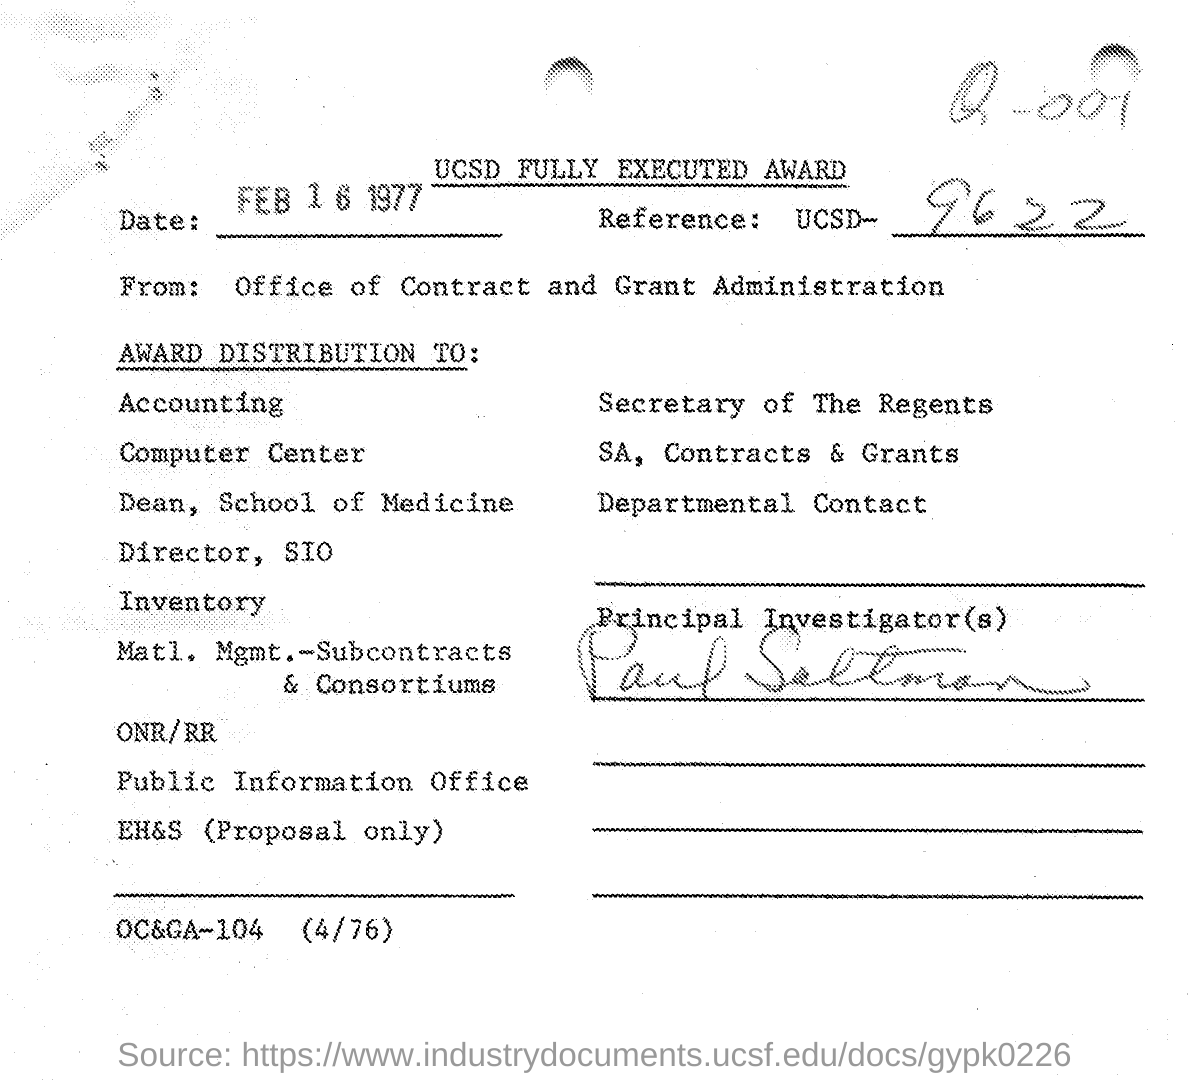Indicate a few pertinent items in this graphic. The Principal Investigator is Paul Saltman. The reference given in this document is UCSD-9622... The date mentioned in this document is February 16, 1977. 